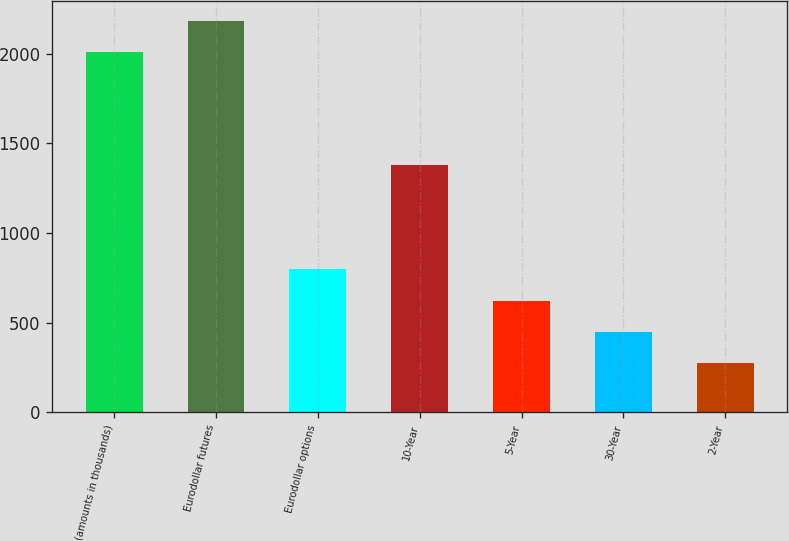Convert chart to OTSL. <chart><loc_0><loc_0><loc_500><loc_500><bar_chart><fcel>(amounts in thousands)<fcel>Eurodollar futures<fcel>Eurodollar options<fcel>10-Year<fcel>5-Year<fcel>30-Year<fcel>2-Year<nl><fcel>2010<fcel>2184.6<fcel>797.8<fcel>1380<fcel>623.2<fcel>448.6<fcel>274<nl></chart> 